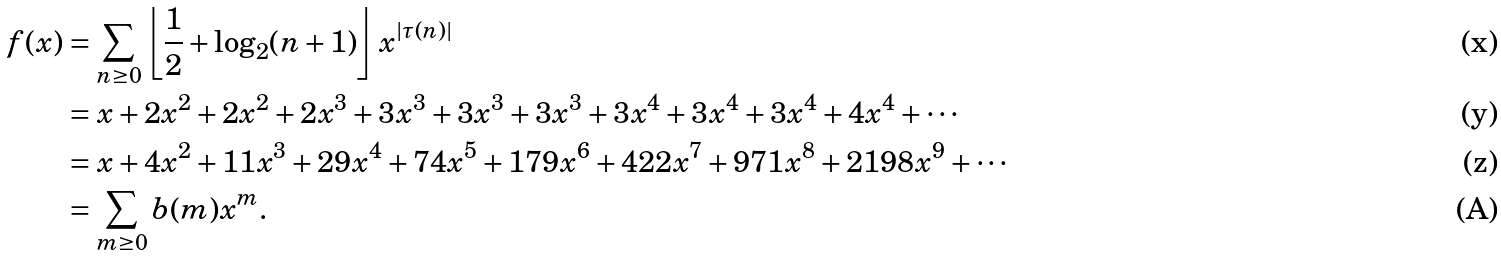<formula> <loc_0><loc_0><loc_500><loc_500>f ( x ) & = \sum _ { n \geq 0 } \left \lfloor \frac { 1 } { 2 } + \log _ { 2 } ( n + 1 ) \right \rfloor x ^ { | \tau ( n ) | } \\ & = x + 2 x ^ { 2 } + 2 x ^ { 2 } + 2 x ^ { 3 } + 3 x ^ { 3 } + 3 x ^ { 3 } + 3 x ^ { 3 } + 3 x ^ { 4 } + 3 x ^ { 4 } + 3 x ^ { 4 } + 4 x ^ { 4 } + \cdots \\ & = x + 4 x ^ { 2 } + 1 1 x ^ { 3 } + 2 9 x ^ { 4 } + 7 4 x ^ { 5 } + 1 7 9 x ^ { 6 } + 4 2 2 x ^ { 7 } + 9 7 1 x ^ { 8 } + 2 1 9 8 x ^ { 9 } + \cdots \\ & = \sum _ { m \geq 0 } b ( m ) x ^ { m } .</formula> 